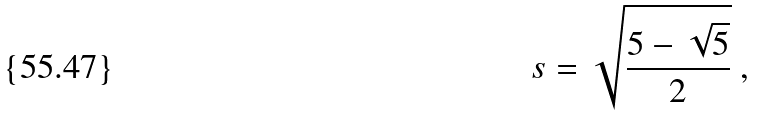Convert formula to latex. <formula><loc_0><loc_0><loc_500><loc_500>s = { \sqrt { \frac { 5 - { \sqrt { 5 } } } { 2 } } } \ ,</formula> 